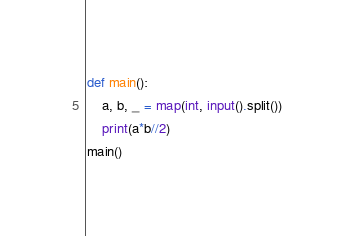Convert code to text. <code><loc_0><loc_0><loc_500><loc_500><_Python_>def main():
    a, b, _ = map(int, input().split())
    print(a*b//2)
main()
</code> 